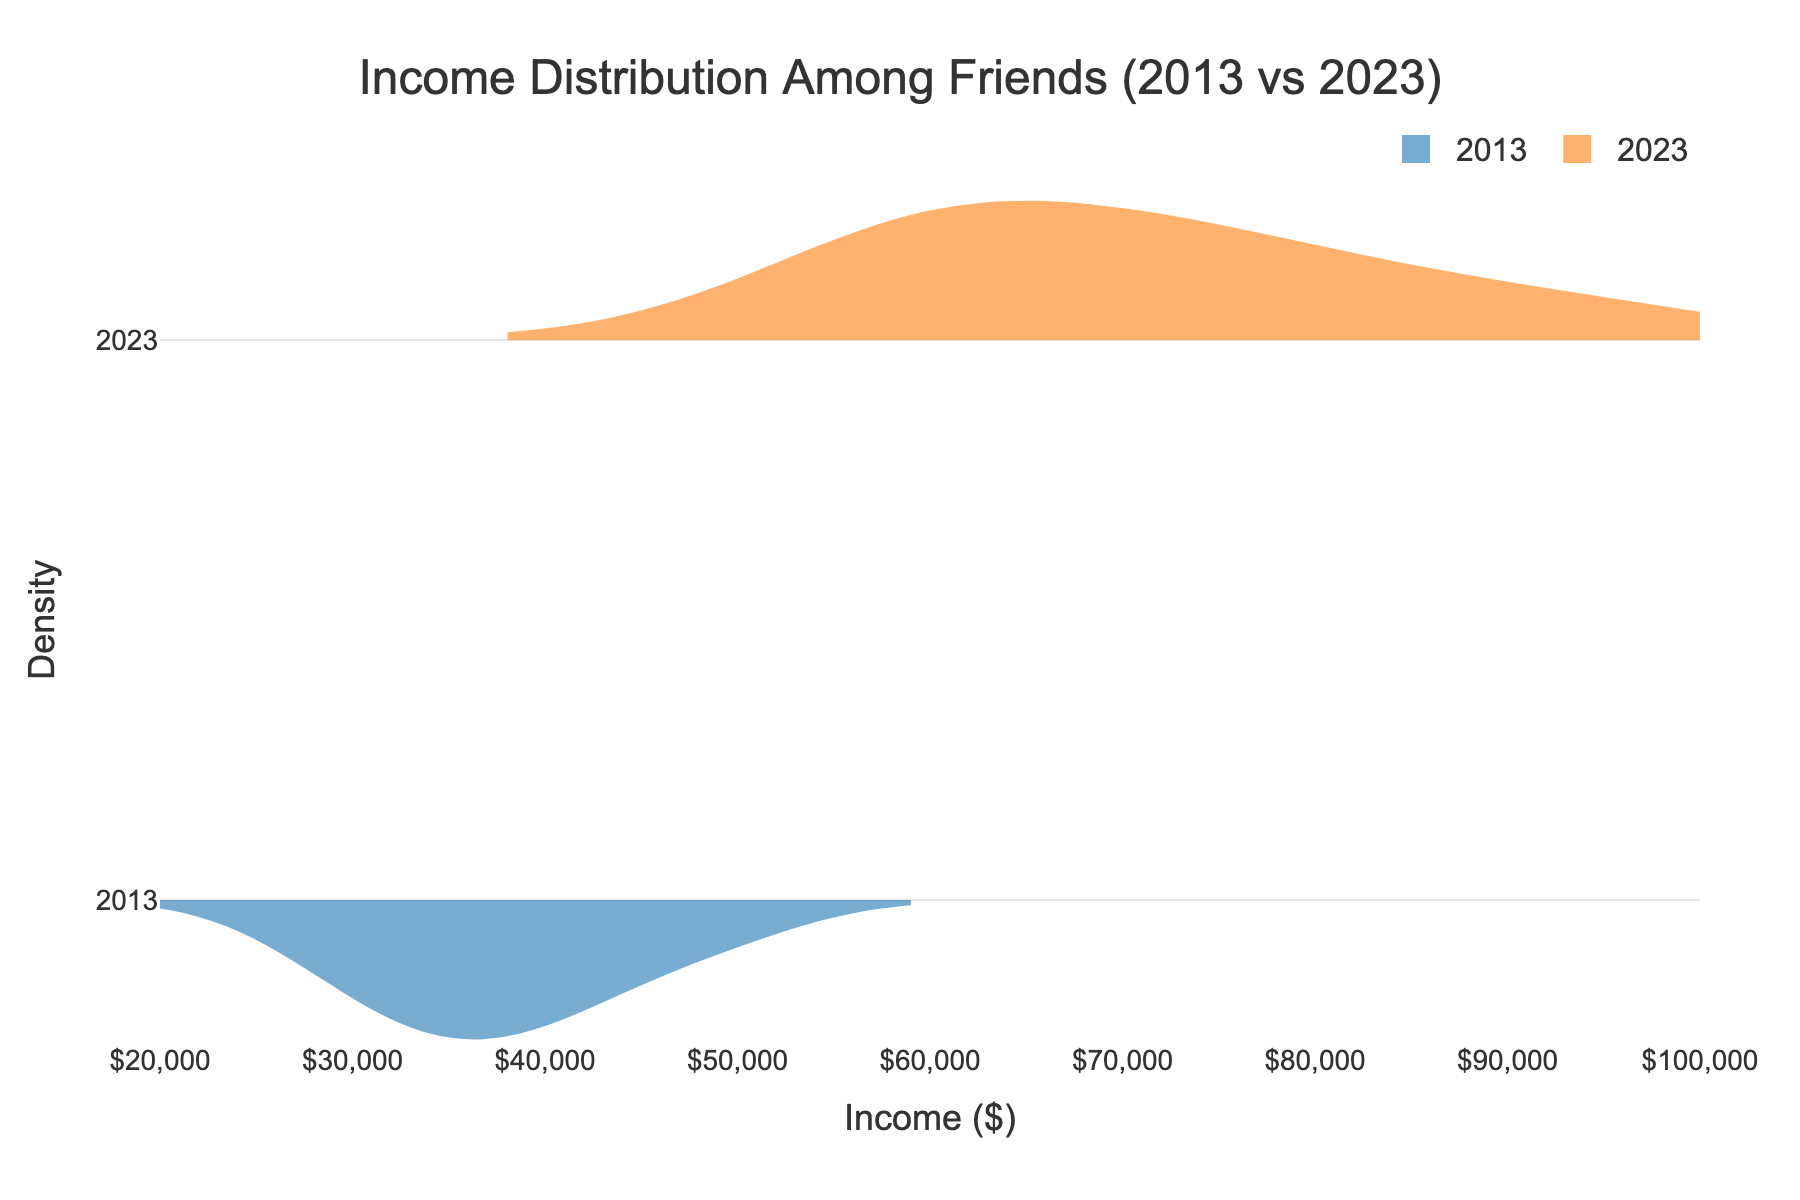what's the title of the figure? The title is printed at the top of the figure centered for clear visibility. It states "Income Distribution Among Friends (2013 vs 2023)."
Answer: Income Distribution Among Friends (2013 vs 2023) what are the x-axis and y-axis titles? The x-axis title is visible below the horizontal axis as "Income ($)", and the y-axis title is visible along the vertical axis as "Density."
Answer: Income ($), Density what colors represent the years 2013 and 2023? The violin plot for 2013 is shaded with a blue color, and the plot for 2023 is shaded with an orange color.
Answer: Blue for 2013, Orange for 2023 what is the income range displayed on the x-axis? The x-axis spans from the specified range of $20,000 to $100,000, covering the lowest and highest incomes.
Answer: $20,000 to $100,000 which year shows higher density at the upper income levels? By observing the density distributions, 2023 (orange-colored) shows higher density at the upper income levels compared to 2013.
Answer: 2023 what’s the median income for 2023 based on the visual distribution? The median income is visually located at the center of the density distribution peak for 2023, approximately around $70,000.
Answer: $70,000 is there a noticeable difference in the income distributions between 2013 and 2023? Yes, the income distributions show an upward shift, with 2023 having higher densities at larger income values, indicating overall income growth.
Answer: Yes how do the densities at the lower income brackets compare between 2013 and 2023? At the lower income brackets, the density for 2013 is higher than for 2023, suggesting fewer people are at the lower income levels in 2023.
Answer: 2013 has higher density what can be inferred about income growth among the friends over the decade? The income distribution shift towards higher values in 2023 suggests that the overall income among friends has grown over the past decade.
Answer: Income has grown 